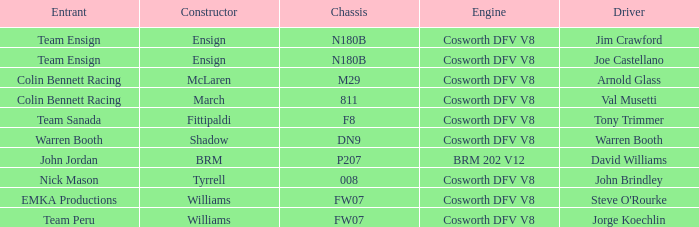What engine is used by Colin Bennett Racing with an 811 chassis? Cosworth DFV V8. 